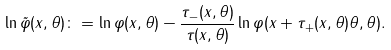Convert formula to latex. <formula><loc_0><loc_0><loc_500><loc_500>\ln \tilde { \varphi } ( x , \theta ) \colon = \ln \varphi ( x , \theta ) - \frac { \tau _ { - } ( x , \theta ) } { \tau ( x , \theta ) } \ln \varphi ( x + \tau _ { + } ( x , \theta ) \theta , \theta ) .</formula> 